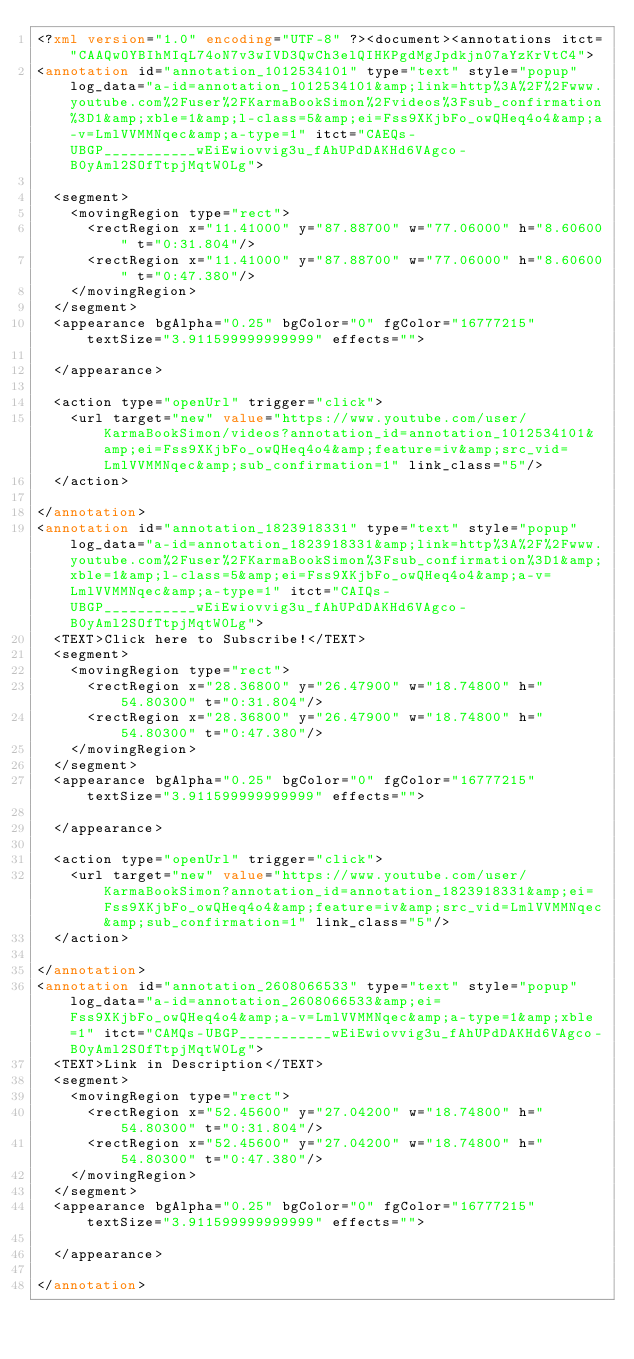<code> <loc_0><loc_0><loc_500><loc_500><_XML_><?xml version="1.0" encoding="UTF-8" ?><document><annotations itct="CAAQwOYBIhMIqL74oN7v3wIVD3QwCh3elQIHKPgdMgJpdkjn07aYzKrVtC4">
<annotation id="annotation_1012534101" type="text" style="popup" log_data="a-id=annotation_1012534101&amp;link=http%3A%2F%2Fwww.youtube.com%2Fuser%2FKarmaBookSimon%2Fvideos%3Fsub_confirmation%3D1&amp;xble=1&amp;l-class=5&amp;ei=Fss9XKjbFo_owQHeq4o4&amp;a-v=LmlVVMMNqec&amp;a-type=1" itct="CAEQs-UBGP___________wEiEwiovvig3u_fAhUPdDAKHd6VAgco-B0yAml2SOfTtpjMqtW0Lg">
  
  <segment>
    <movingRegion type="rect">
      <rectRegion x="11.41000" y="87.88700" w="77.06000" h="8.60600" t="0:31.804"/>
      <rectRegion x="11.41000" y="87.88700" w="77.06000" h="8.60600" t="0:47.380"/>
    </movingRegion>
  </segment>
  <appearance bgAlpha="0.25" bgColor="0" fgColor="16777215" textSize="3.911599999999999" effects="">
    
  </appearance>
  
  <action type="openUrl" trigger="click">
    <url target="new" value="https://www.youtube.com/user/KarmaBookSimon/videos?annotation_id=annotation_1012534101&amp;ei=Fss9XKjbFo_owQHeq4o4&amp;feature=iv&amp;src_vid=LmlVVMMNqec&amp;sub_confirmation=1" link_class="5"/>
  </action>

</annotation>
<annotation id="annotation_1823918331" type="text" style="popup" log_data="a-id=annotation_1823918331&amp;link=http%3A%2F%2Fwww.youtube.com%2Fuser%2FKarmaBookSimon%3Fsub_confirmation%3D1&amp;xble=1&amp;l-class=5&amp;ei=Fss9XKjbFo_owQHeq4o4&amp;a-v=LmlVVMMNqec&amp;a-type=1" itct="CAIQs-UBGP___________wEiEwiovvig3u_fAhUPdDAKHd6VAgco-B0yAml2SOfTtpjMqtW0Lg">
  <TEXT>Click here to Subscribe!</TEXT>
  <segment>
    <movingRegion type="rect">
      <rectRegion x="28.36800" y="26.47900" w="18.74800" h="54.80300" t="0:31.804"/>
      <rectRegion x="28.36800" y="26.47900" w="18.74800" h="54.80300" t="0:47.380"/>
    </movingRegion>
  </segment>
  <appearance bgAlpha="0.25" bgColor="0" fgColor="16777215" textSize="3.911599999999999" effects="">
    
  </appearance>
  
  <action type="openUrl" trigger="click">
    <url target="new" value="https://www.youtube.com/user/KarmaBookSimon?annotation_id=annotation_1823918331&amp;ei=Fss9XKjbFo_owQHeq4o4&amp;feature=iv&amp;src_vid=LmlVVMMNqec&amp;sub_confirmation=1" link_class="5"/>
  </action>

</annotation>
<annotation id="annotation_2608066533" type="text" style="popup" log_data="a-id=annotation_2608066533&amp;ei=Fss9XKjbFo_owQHeq4o4&amp;a-v=LmlVVMMNqec&amp;a-type=1&amp;xble=1" itct="CAMQs-UBGP___________wEiEwiovvig3u_fAhUPdDAKHd6VAgco-B0yAml2SOfTtpjMqtW0Lg">
  <TEXT>Link in Description</TEXT>
  <segment>
    <movingRegion type="rect">
      <rectRegion x="52.45600" y="27.04200" w="18.74800" h="54.80300" t="0:31.804"/>
      <rectRegion x="52.45600" y="27.04200" w="18.74800" h="54.80300" t="0:47.380"/>
    </movingRegion>
  </segment>
  <appearance bgAlpha="0.25" bgColor="0" fgColor="16777215" textSize="3.911599999999999" effects="">
    
  </appearance>
  
</annotation></code> 